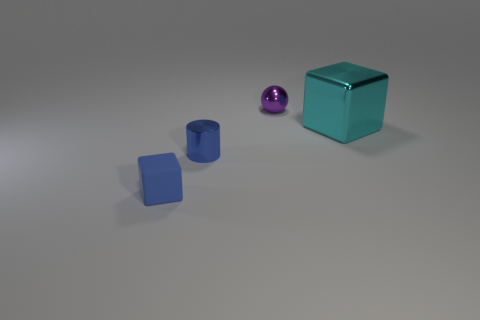Is there anything else that has the same size as the metal cube?
Your response must be concise. No. There is a thing that is both in front of the small purple metallic ball and on the right side of the cylinder; what is it made of?
Your answer should be very brief. Metal. Is the number of cylinders right of the blue shiny cylinder less than the number of small cylinders in front of the large cyan shiny thing?
Provide a succinct answer. Yes. How many other objects are the same size as the purple thing?
Make the answer very short. 2. There is a tiny blue thing on the right side of the small blue thing on the left side of the tiny shiny thing in front of the purple sphere; what shape is it?
Your answer should be very brief. Cylinder. How many gray things are tiny metallic balls or metal cylinders?
Keep it short and to the point. 0. There is a tiny thing that is on the right side of the small blue shiny cylinder; what number of small blue metallic things are left of it?
Offer a very short reply. 1. Are there any other things that have the same color as the matte cube?
Provide a short and direct response. Yes. There is a cyan thing that is the same material as the tiny purple sphere; what shape is it?
Keep it short and to the point. Cube. Do the shiny cube and the tiny cylinder have the same color?
Provide a succinct answer. No. 